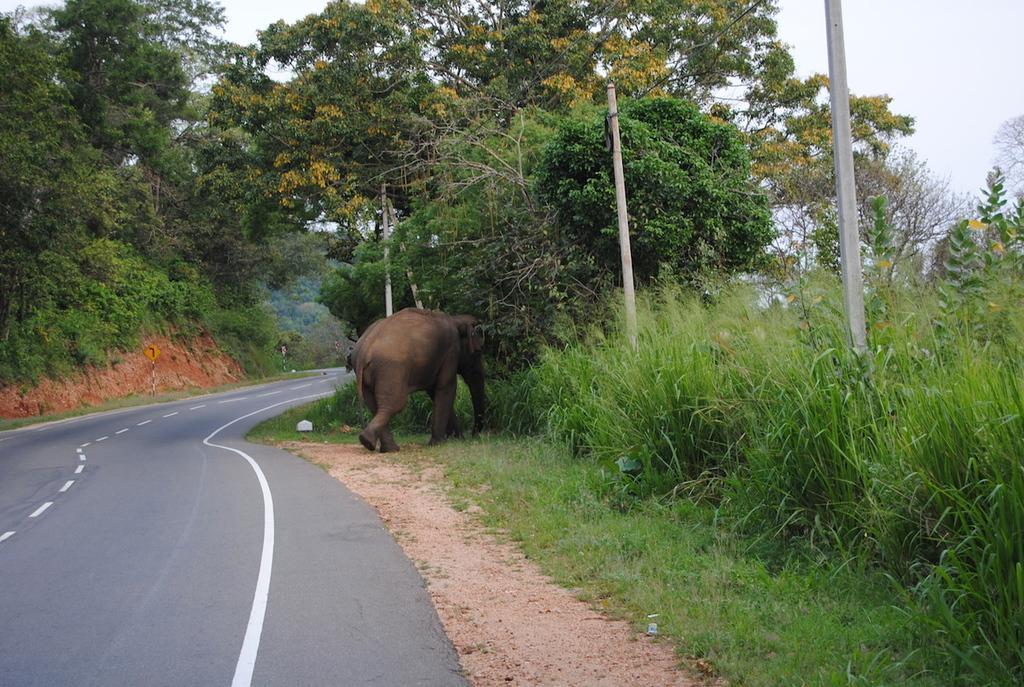How would you summarize this image in a sentence or two? This image consists of an elephant walking. On the left, there is a road. At the bottom, we can see green grass on the ground. In the background, there are trees. At the top, there is sky. On the right, there are poles. 